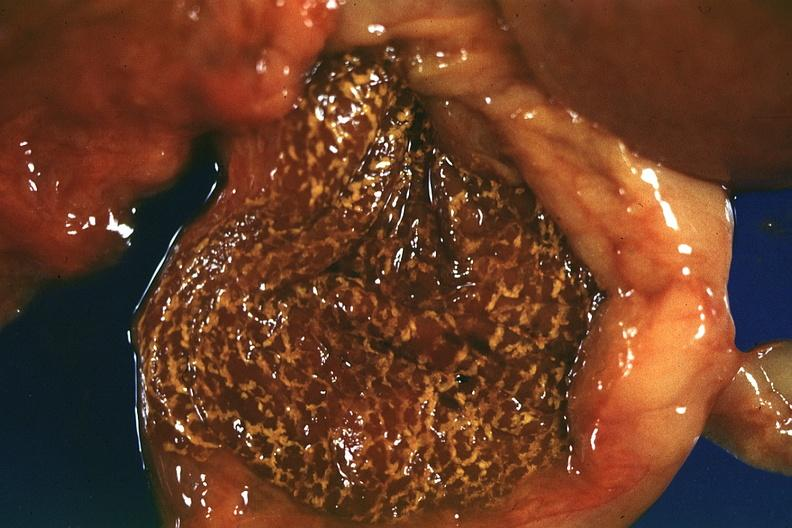what is present?
Answer the question using a single word or phrase. Liver 